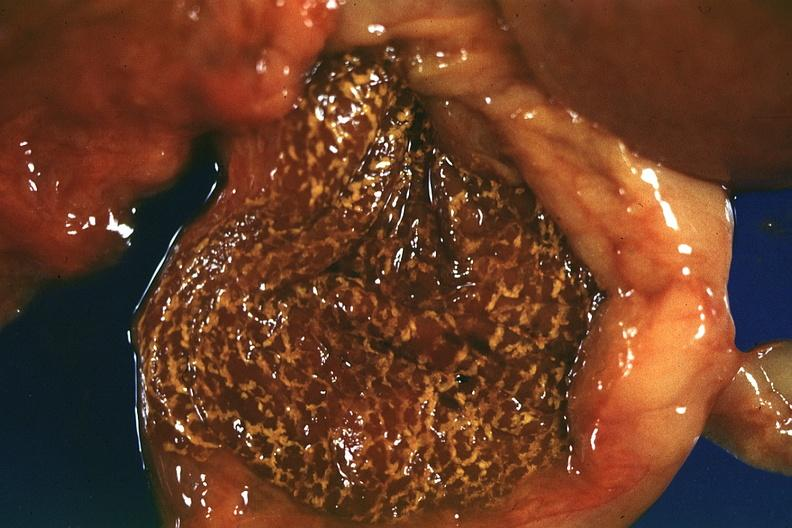what is present?
Answer the question using a single word or phrase. Liver 